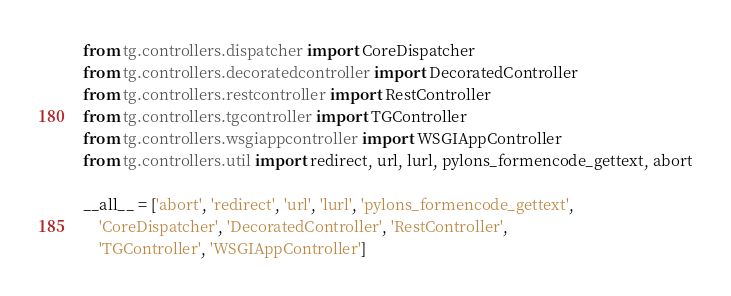Convert code to text. <code><loc_0><loc_0><loc_500><loc_500><_Python_>from tg.controllers.dispatcher import CoreDispatcher
from tg.controllers.decoratedcontroller import DecoratedController
from tg.controllers.restcontroller import RestController
from tg.controllers.tgcontroller import TGController
from tg.controllers.wsgiappcontroller import WSGIAppController
from tg.controllers.util import redirect, url, lurl, pylons_formencode_gettext, abort

__all__ = ['abort', 'redirect', 'url', 'lurl', 'pylons_formencode_gettext',
    'CoreDispatcher', 'DecoratedController', 'RestController',
    'TGController', 'WSGIAppController']

</code> 